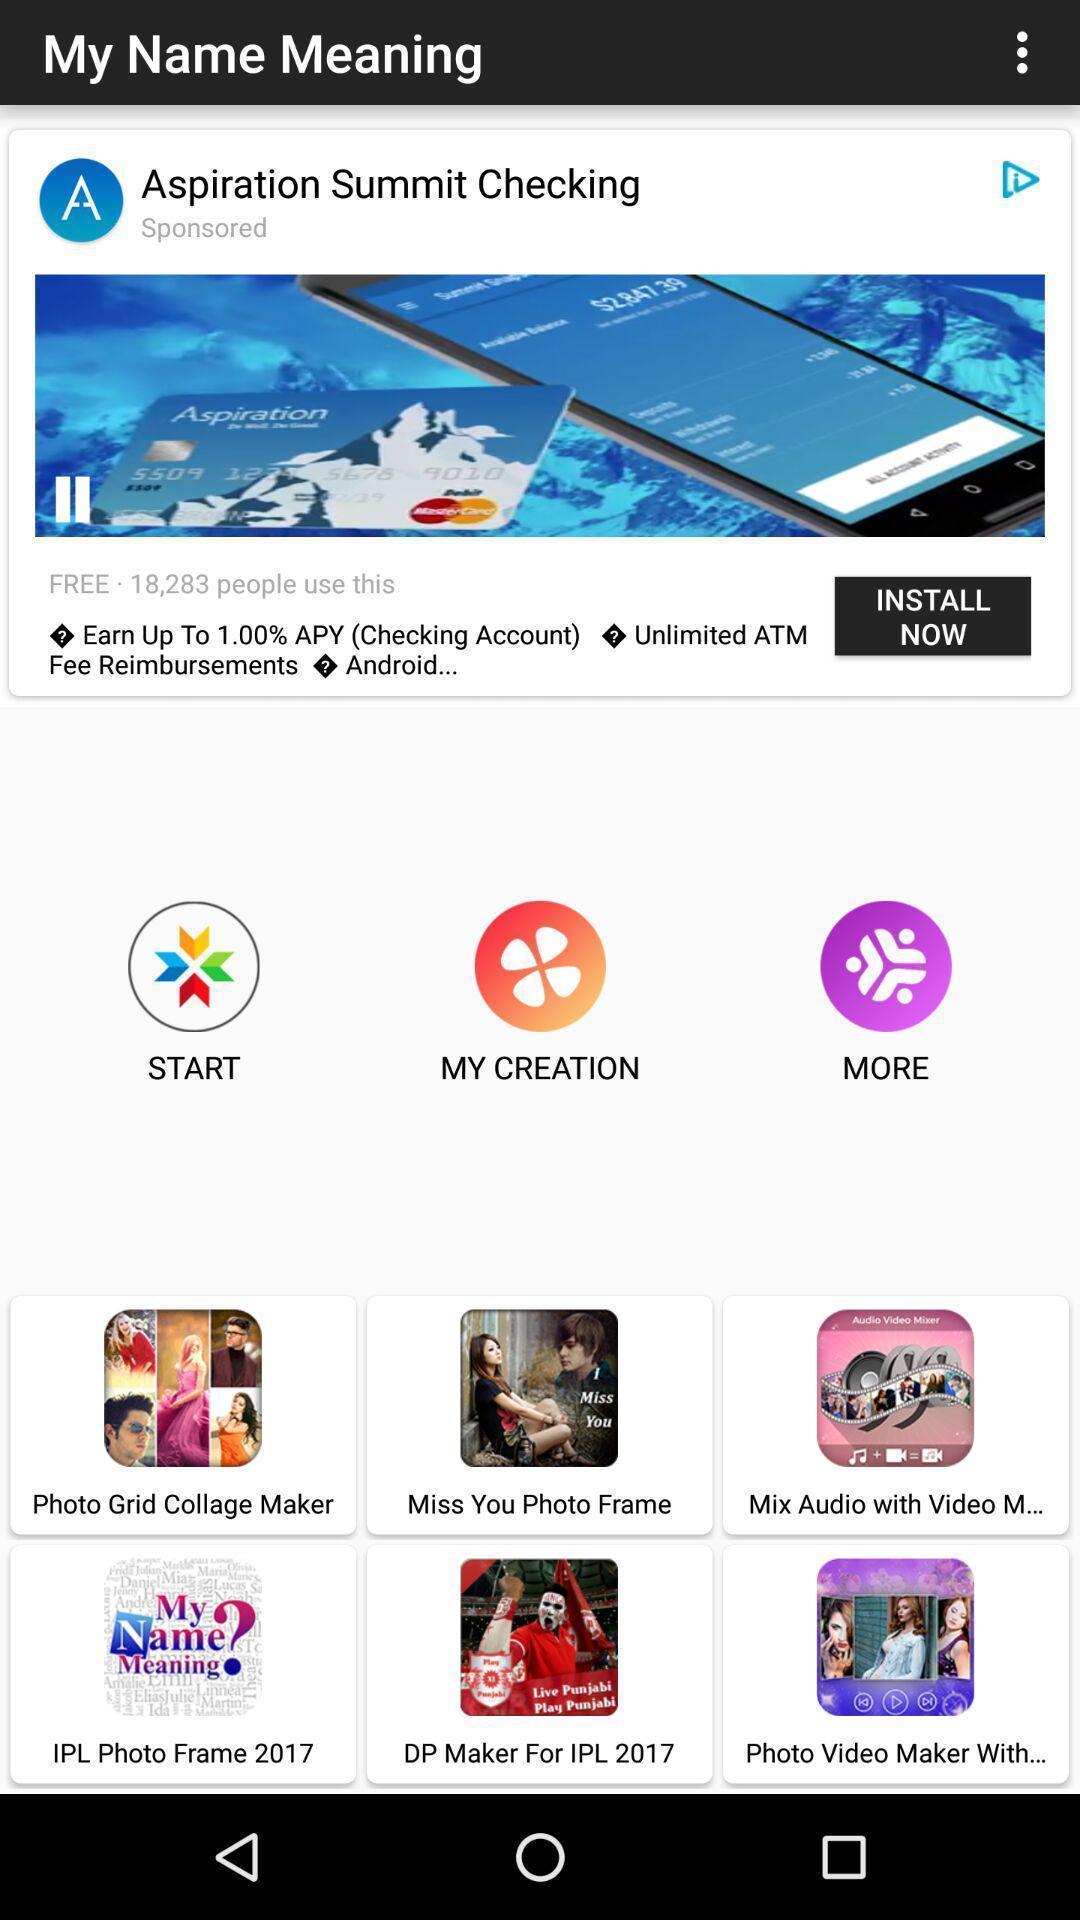Explain what's happening in this screen capture. Start page of a photo frame app. 